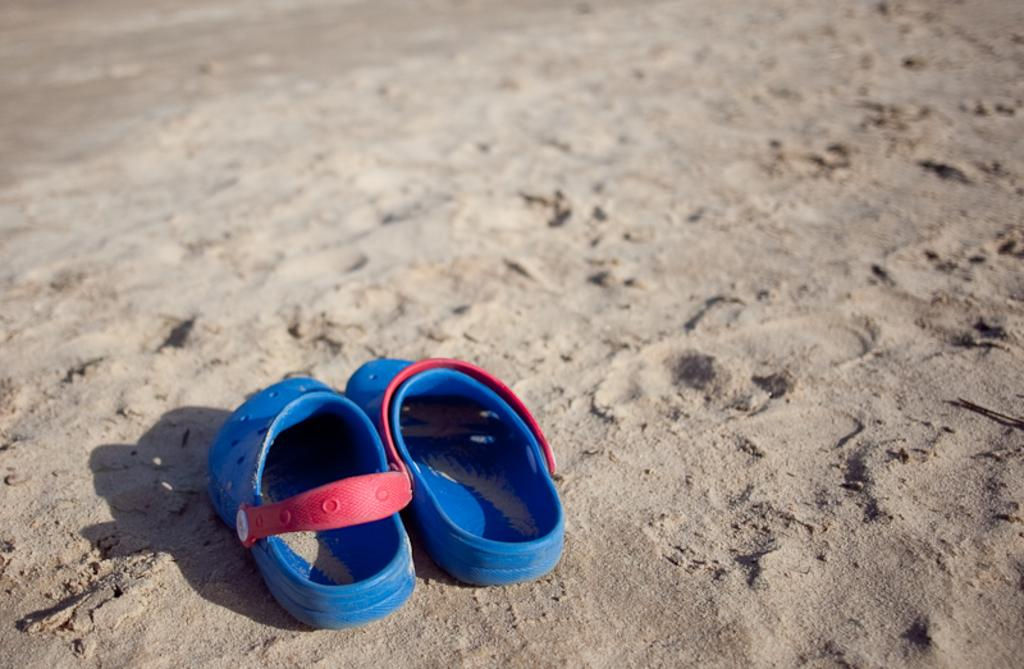What type of footwear is present in the image? There are blue color slippers in the image. What can be seen at the bottom of the image? There is sand visible at the bottom of the image. What type of hammer can be seen in the image? There is no hammer present in the image. What type of land is visible in the image? The image does not show any land; it only shows sand. 